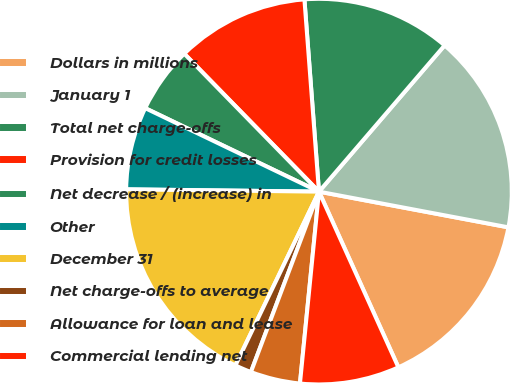Convert chart. <chart><loc_0><loc_0><loc_500><loc_500><pie_chart><fcel>Dollars in millions<fcel>January 1<fcel>Total net charge-offs<fcel>Provision for credit losses<fcel>Net decrease / (increase) in<fcel>Other<fcel>December 31<fcel>Net charge-offs to average<fcel>Allowance for loan and lease<fcel>Commercial lending net<nl><fcel>15.28%<fcel>16.67%<fcel>12.5%<fcel>11.11%<fcel>5.56%<fcel>6.94%<fcel>18.06%<fcel>1.39%<fcel>4.17%<fcel>8.33%<nl></chart> 